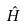<formula> <loc_0><loc_0><loc_500><loc_500>\hat { H }</formula> 